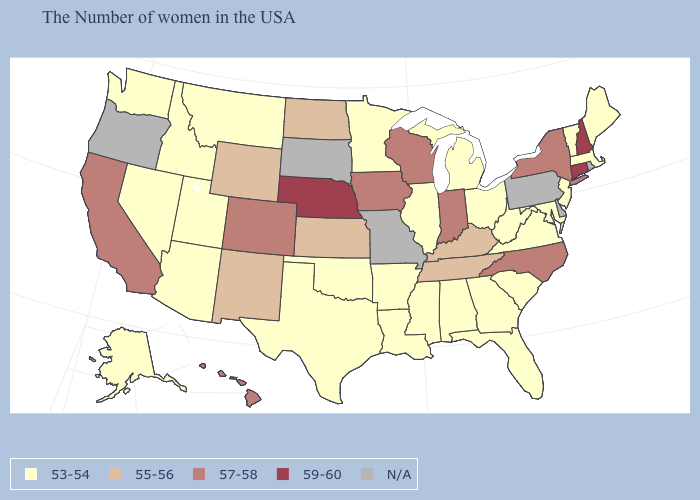What is the value of South Carolina?
Quick response, please. 53-54. What is the lowest value in states that border Montana?
Answer briefly. 53-54. Name the states that have a value in the range 55-56?
Write a very short answer. Kentucky, Tennessee, Kansas, North Dakota, Wyoming, New Mexico. What is the value of Maryland?
Answer briefly. 53-54. Does Georgia have the highest value in the USA?
Concise answer only. No. Among the states that border Illinois , does Indiana have the lowest value?
Be succinct. No. What is the value of Indiana?
Be succinct. 57-58. Name the states that have a value in the range 57-58?
Answer briefly. New York, North Carolina, Indiana, Wisconsin, Iowa, Colorado, California, Hawaii. What is the highest value in the USA?
Short answer required. 59-60. What is the value of Virginia?
Write a very short answer. 53-54. Does Connecticut have the highest value in the USA?
Be succinct. Yes. What is the value of Alabama?
Answer briefly. 53-54. Name the states that have a value in the range 59-60?
Quick response, please. New Hampshire, Connecticut, Nebraska. 